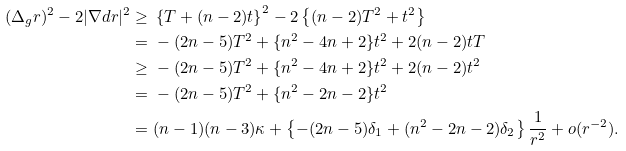Convert formula to latex. <formula><loc_0><loc_0><loc_500><loc_500>( \Delta _ { g } r ) ^ { 2 } - 2 | \nabla d r | ^ { 2 } \geq & \ \left \{ T + ( n - 2 ) t \right \} ^ { 2 } - 2 \left \{ ( n - 2 ) T ^ { 2 } + t ^ { 2 } \right \} \\ = & \ - ( 2 n - 5 ) T ^ { 2 } + \{ n ^ { 2 } - 4 n + 2 \} t ^ { 2 } + 2 ( n - 2 ) t T \\ \geq & \ - ( 2 n - 5 ) T ^ { 2 } + \{ n ^ { 2 } - 4 n + 2 \} t ^ { 2 } + 2 ( n - 2 ) t ^ { 2 } \\ = & \ - ( 2 n - 5 ) T ^ { 2 } + \{ n ^ { 2 } - 2 n - 2 \} t ^ { 2 } \\ = & \ ( n - 1 ) ( n - 3 ) \kappa + \left \{ - ( 2 n - 5 ) \delta _ { 1 } + ( n ^ { 2 } - 2 n - 2 ) \delta _ { 2 } \right \} \frac { 1 } { r ^ { 2 } } + o ( r ^ { - 2 } ) .</formula> 